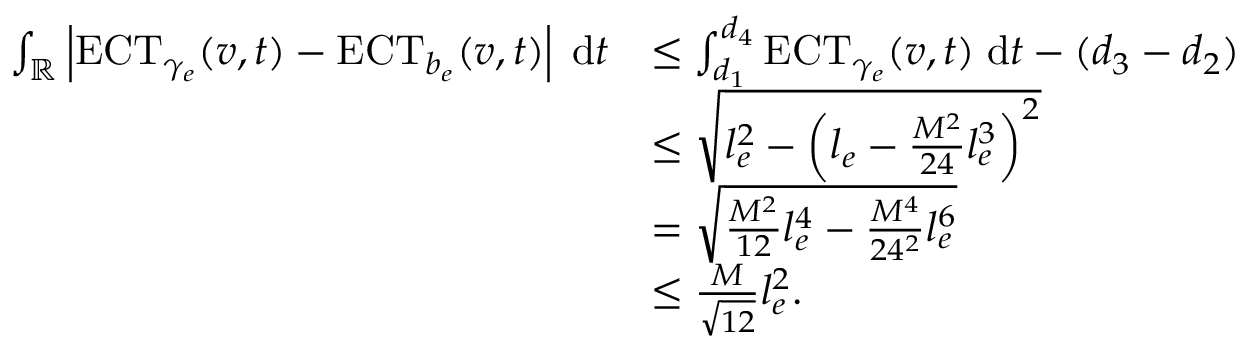Convert formula to latex. <formula><loc_0><loc_0><loc_500><loc_500>\begin{array} { r l } { \int _ { \mathbb { R } } \left | E C T _ { \gamma _ { e } } ( v , t ) - E C T _ { b _ { e } } ( v , t ) \right | \, d t } & { \leq \int _ { d _ { 1 } } ^ { d _ { 4 } } E C T _ { \gamma _ { e } } ( v , t ) \, d t - ( d _ { 3 } - d _ { 2 } ) } \\ & { \leq \sqrt { l _ { e } ^ { 2 } - \left ( l _ { e } - \frac { M ^ { 2 } } { 2 4 } l _ { e } ^ { 3 } \right ) ^ { 2 } } } \\ & { = \sqrt { \frac { M ^ { 2 } } { 1 2 } l _ { e } ^ { 4 } - \frac { M ^ { 4 } } { 2 4 ^ { 2 } } l _ { e } ^ { 6 } } } \\ & { \leq \frac { M } { \sqrt { 1 2 } } l _ { e } ^ { 2 } . } \end{array}</formula> 